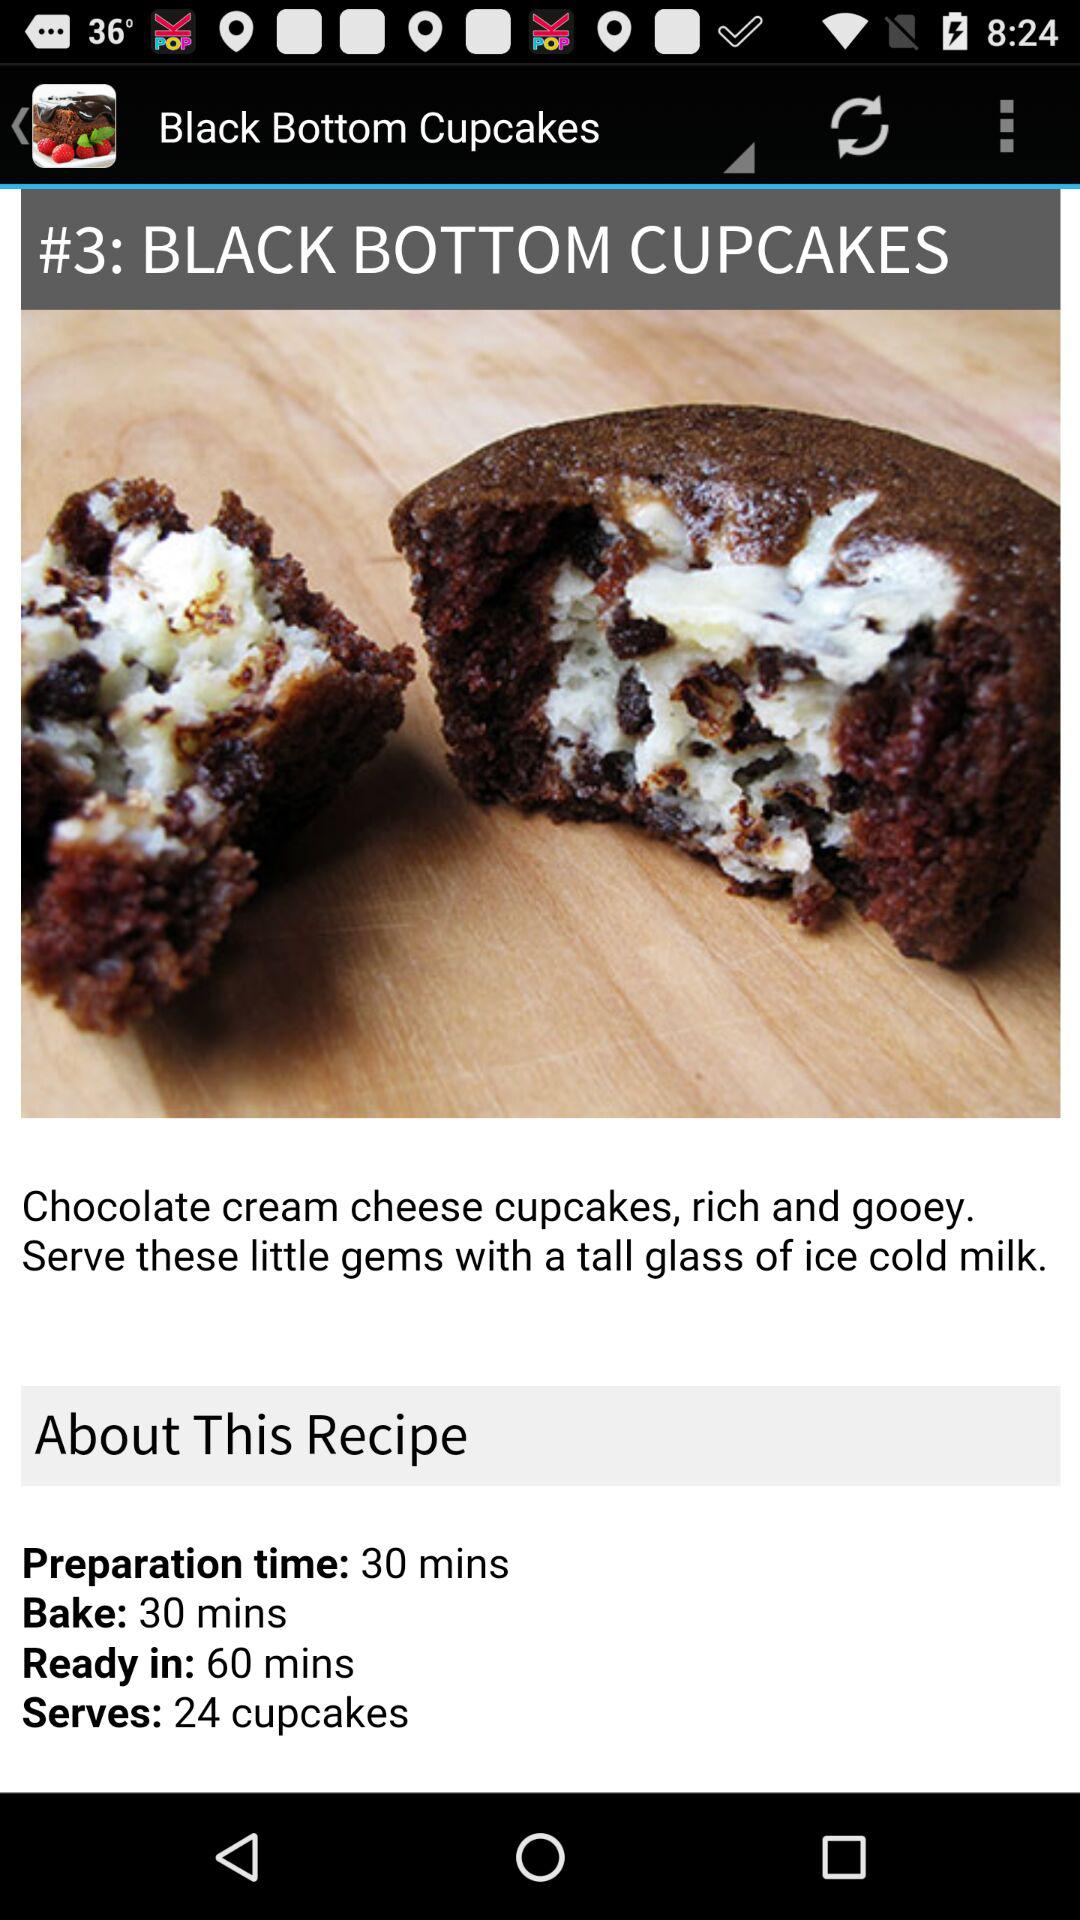What's the dish name? The dish name is "BLACK BOTTOM CUPCAKES". 